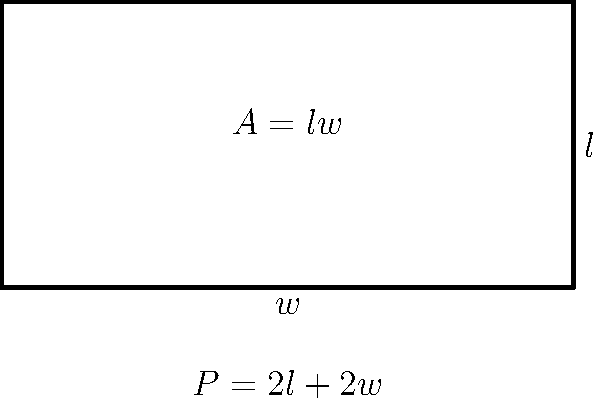Lora Slavcheva is designing a rectangular enclosure for her latest art installation. The perimeter of the enclosure is fixed at 120 meters. What dimensions should Lora choose to maximize the area of the enclosure, and what is the maximum area? Let's approach this step-by-step:

1) Let $l$ be the length and $w$ be the width of the rectangle.

2) Given that the perimeter is 120 meters, we can write:
   $2l + 2w = 120$
   $l + w = 60$
   $l = 60 - w$

3) The area $A$ of the rectangle is given by:
   $A = lw = (60-w)w = 60w - w^2$

4) To find the maximum area, we need to find where the derivative of $A$ with respect to $w$ is zero:
   $\frac{dA}{dw} = 60 - 2w$

5) Setting this equal to zero:
   $60 - 2w = 0$
   $2w = 60$
   $w = 30$

6) Since $l = 60 - w$, we also have $l = 30$

7) The second derivative $\frac{d^2A}{dw^2} = -2$ is negative, confirming this is a maximum.

8) Therefore, the maximum area occurs when $l = w = 30$ meters.

9) The maximum area is:
   $A = lw = 30 * 30 = 900$ square meters
Answer: Length = 30 m, Width = 30 m, Maximum Area = 900 m² 